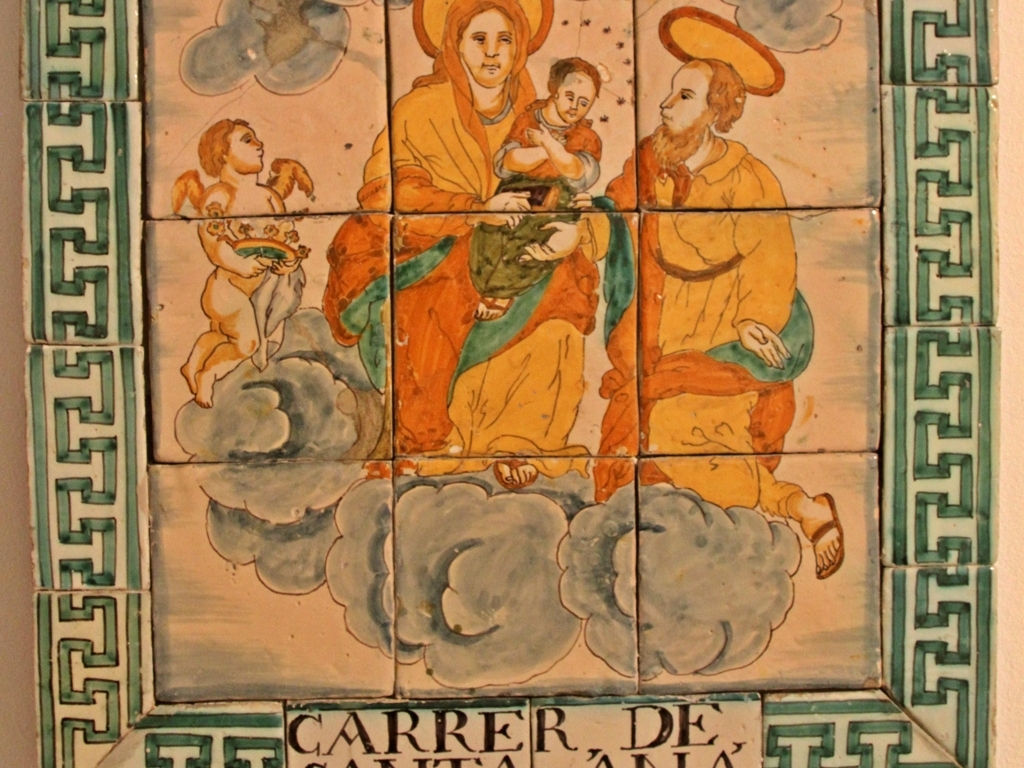Is the image pixelated? No, the image is not pixelated. The clarity and details are well preserved, showcasing the vibrancy and intricacies of the colors and patterns on the ceramic tiles. 